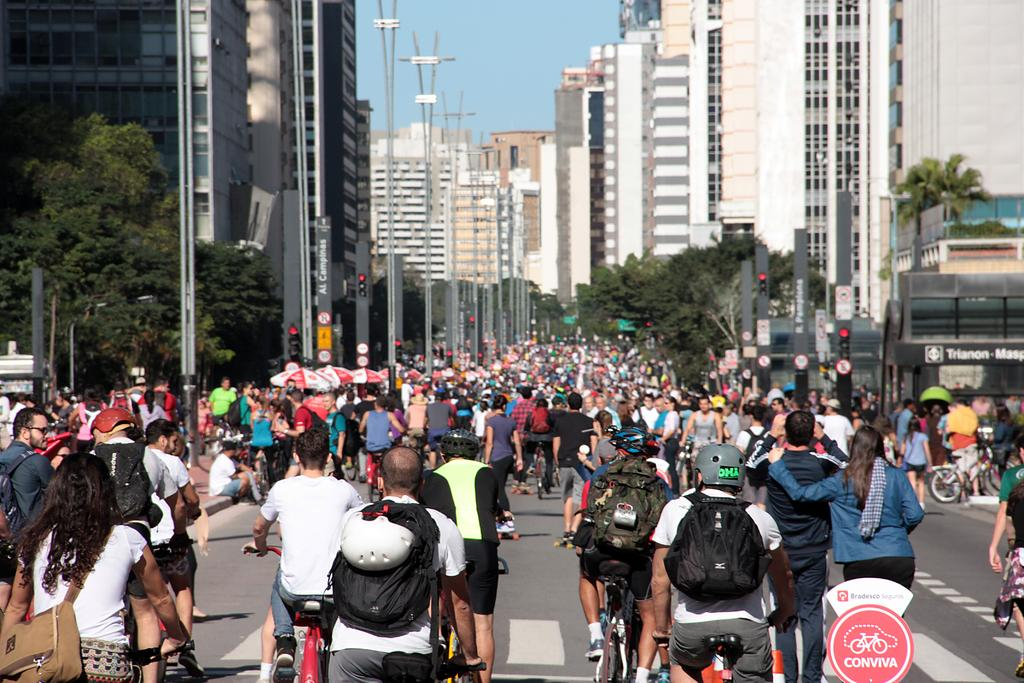What are the people in the image doing? The people in the image are cycling. What can be seen on the left side of the image? There are buildings and trees on the left side of the image. What can be seen on the right side of the image? There are buildings and trees on the right side of the image. What structures are present in the image for providing electricity? Current poles are present in the image. What type of coat is the goldfish wearing in the image? There is no goldfish present in the image, and therefore no coat can be observed. 